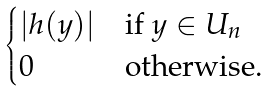Convert formula to latex. <formula><loc_0><loc_0><loc_500><loc_500>\begin{cases} | h ( y ) | & \text {if $y \in U_{n}$} \\ 0 & \text {otherwise} . \end{cases}</formula> 